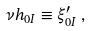Convert formula to latex. <formula><loc_0><loc_0><loc_500><loc_500>\nu h _ { 0 I } \equiv \xi ^ { \prime } _ { 0 I } \, ,</formula> 